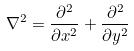<formula> <loc_0><loc_0><loc_500><loc_500>\nabla ^ { 2 } = \frac { \partial ^ { 2 } } { \partial x ^ { 2 } } + \frac { \partial ^ { 2 } } { \partial y ^ { 2 } }</formula> 